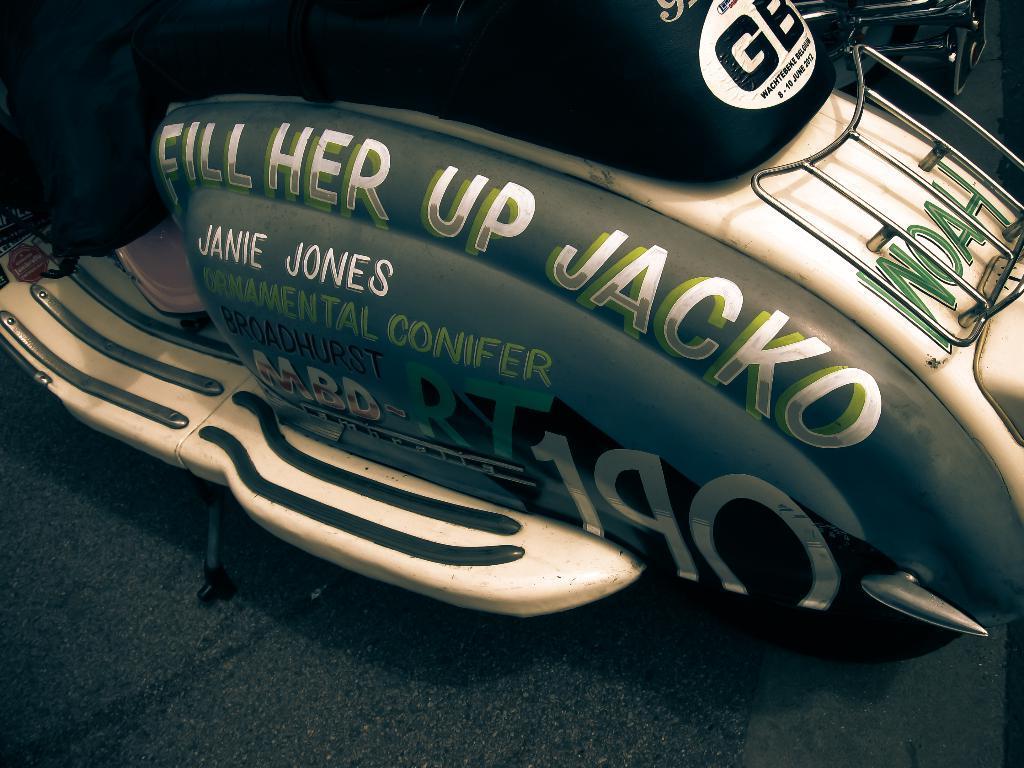Could you give a brief overview of what you see in this image? This looks like an edited image. There is a vehicle in the middle. It looks like a scooter. There is something written on that. 